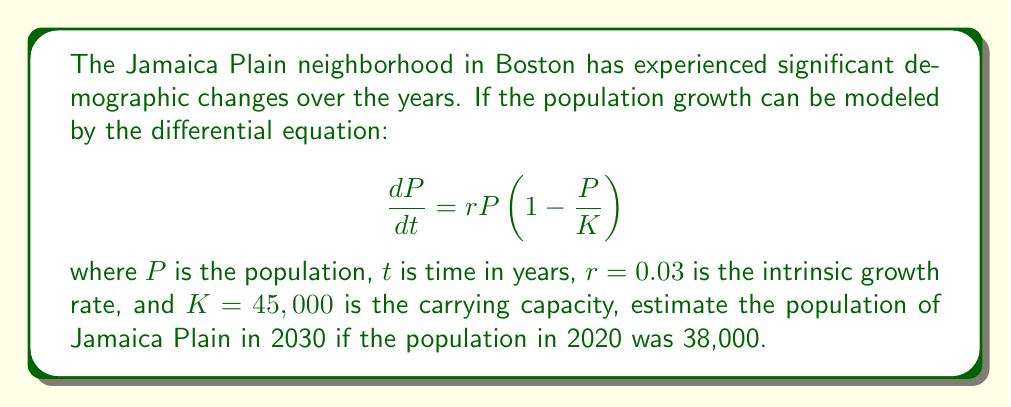Provide a solution to this math problem. To solve this problem, we need to use the logistic growth model, which is described by the given differential equation. This model accounts for population growth that slows as it approaches a carrying capacity.

1) First, we need to solve the differential equation. The solution to the logistic growth equation is:

   $$P(t) = \frac{K}{1 + \left(\frac{K}{P_0} - 1\right)e^{-rt}}$$

   where $P_0$ is the initial population.

2) We're given the following values:
   - $K = 45,000$ (carrying capacity)
   - $r = 0.03$ (intrinsic growth rate)
   - $P_0 = 38,000$ (population in 2020)
   - $t = 10$ (we're estimating for 2030, which is 10 years after 2020)

3) Let's substitute these values into our equation:

   $$P(10) = \frac{45,000}{1 + \left(\frac{45,000}{38,000} - 1\right)e^{-0.03 \cdot 10}}$$

4) Simplify the fraction inside the parentheses:

   $$P(10) = \frac{45,000}{1 + (1.1842 - 1)e^{-0.3}}$$

5) Calculate the exponent:
   $e^{-0.3} \approx 0.7408$

6) Substitute this value:

   $$P(10) = \frac{45,000}{1 + 0.1842 \cdot 0.7408}$$

7) Calculate the denominator:
   $1 + 0.1842 \cdot 0.7408 \approx 1.1365$

8) Finally, divide:

   $$P(10) = \frac{45,000}{1.1365} \approx 39,595$$

Therefore, the estimated population of Jamaica Plain in 2030 is approximately 39,595 people.
Answer: 39,595 people 